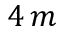Convert formula to latex. <formula><loc_0><loc_0><loc_500><loc_500>4 \, m</formula> 